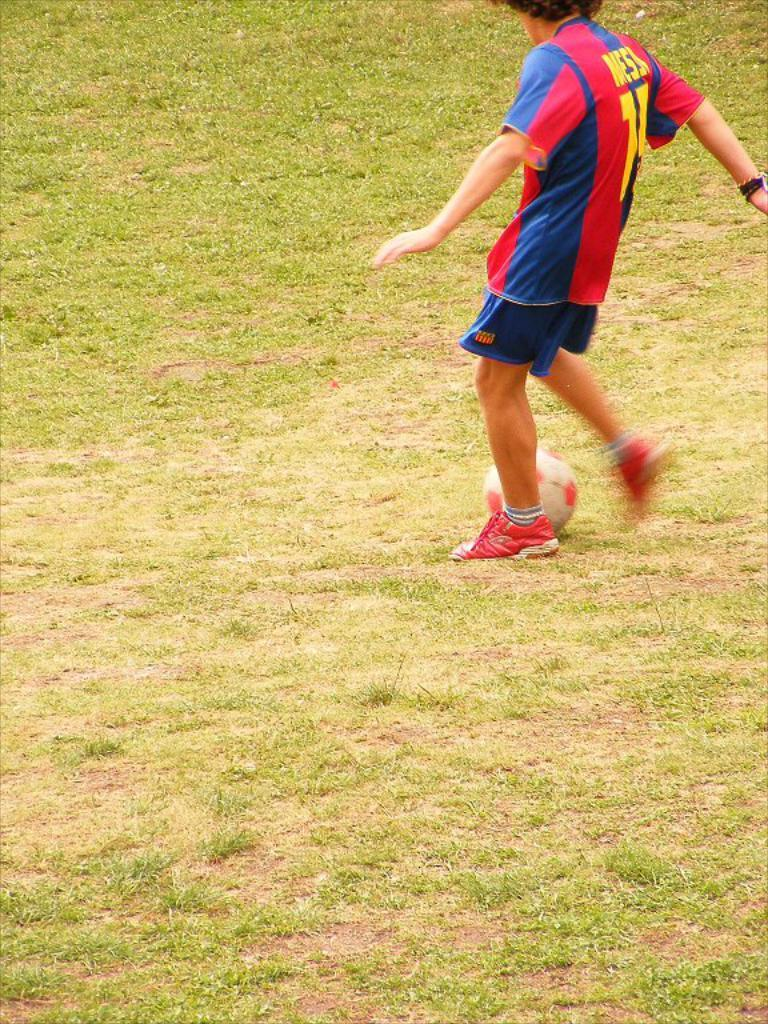<image>
Render a clear and concise summary of the photo. Man wearing a Messi jersey about to kick a soccer ball on the field. 